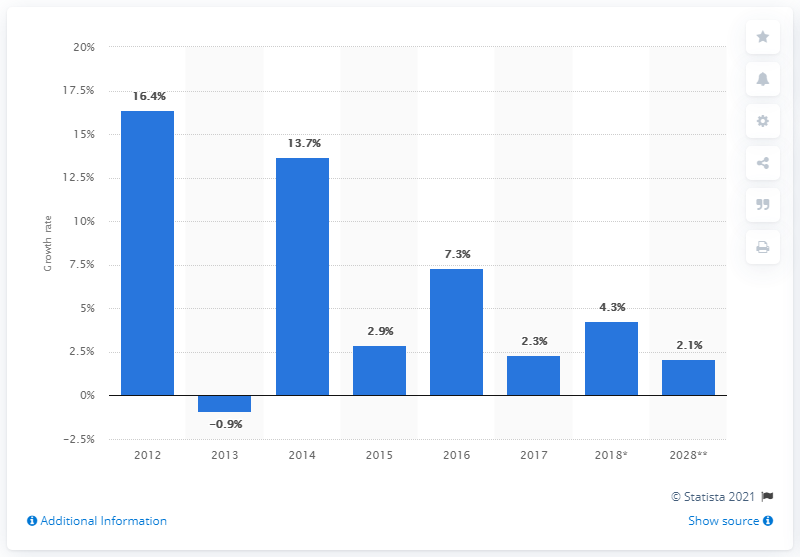Which year shows a negative blue bar?
 2013 